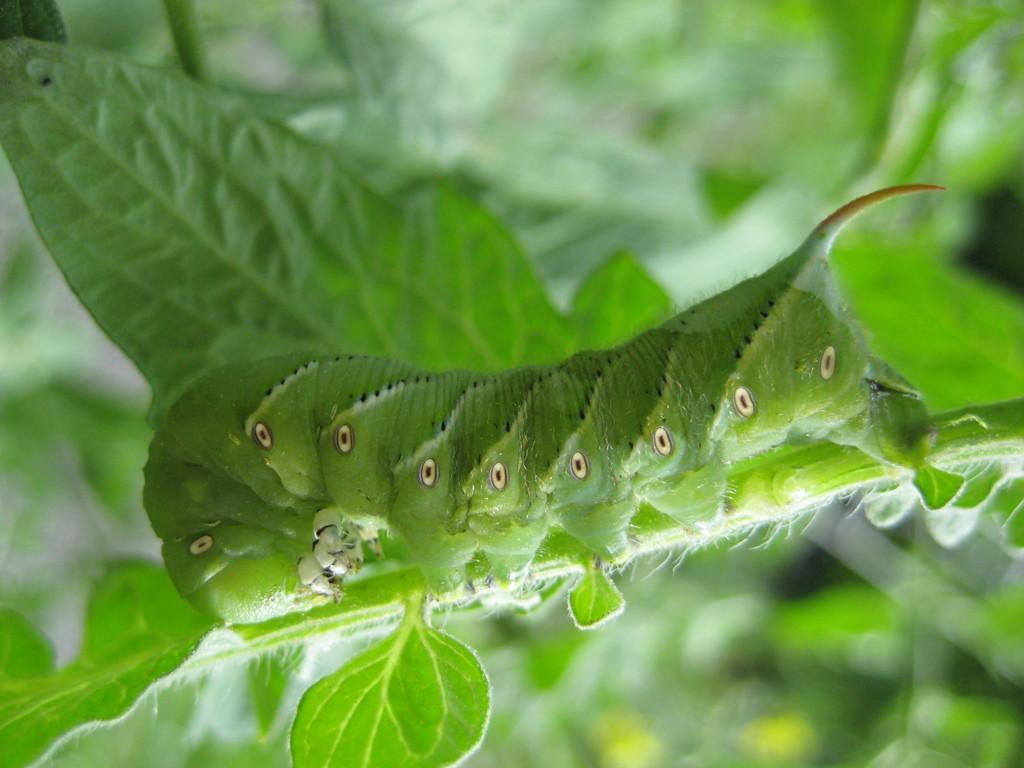Could you give a brief overview of what you see in this image? Here we can see an insect on a plant. In the background the image is blur but we can see leaves. 